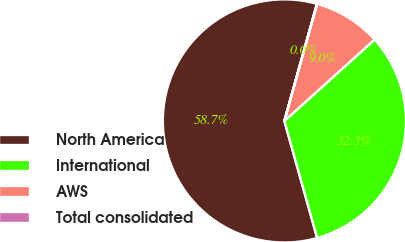<chart> <loc_0><loc_0><loc_500><loc_500><pie_chart><fcel>North America<fcel>International<fcel>AWS<fcel>Total consolidated<nl><fcel>58.66%<fcel>32.34%<fcel>8.98%<fcel>0.02%<nl></chart> 